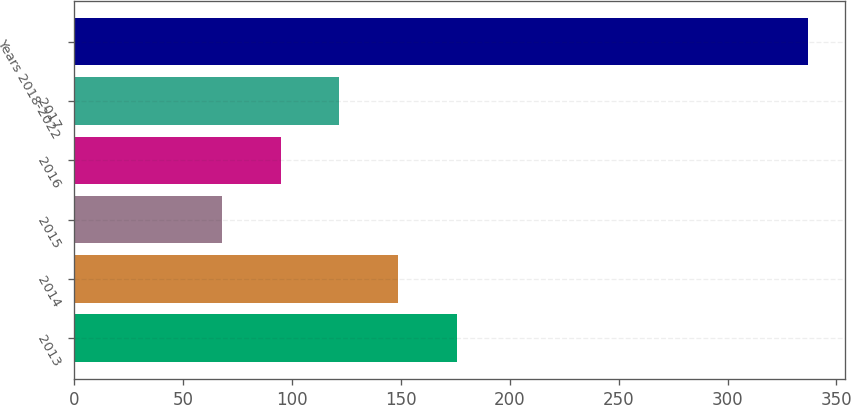Convert chart to OTSL. <chart><loc_0><loc_0><loc_500><loc_500><bar_chart><fcel>2013<fcel>2014<fcel>2015<fcel>2016<fcel>2017<fcel>Years 2018-2022<nl><fcel>175.6<fcel>148.7<fcel>68<fcel>94.9<fcel>121.8<fcel>337<nl></chart> 